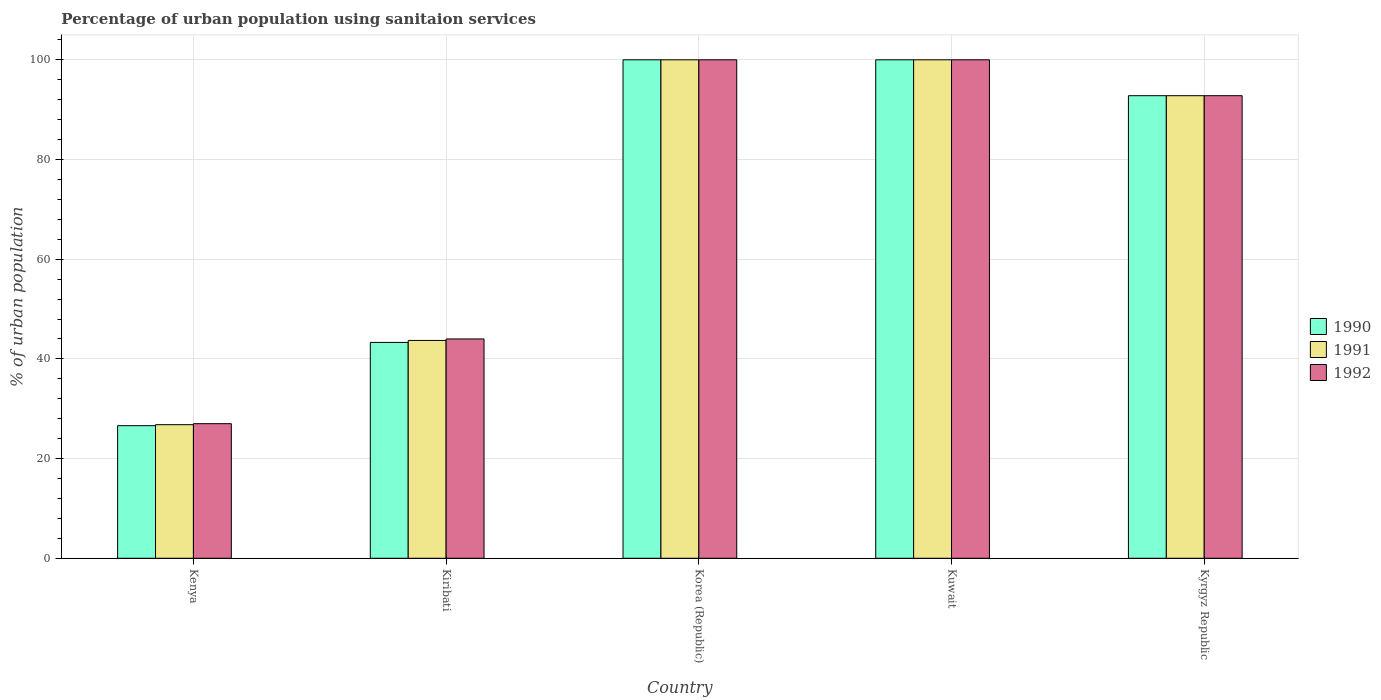How many groups of bars are there?
Provide a succinct answer. 5. Are the number of bars on each tick of the X-axis equal?
Keep it short and to the point. Yes. How many bars are there on the 3rd tick from the left?
Offer a terse response. 3. How many bars are there on the 1st tick from the right?
Make the answer very short. 3. What is the label of the 5th group of bars from the left?
Ensure brevity in your answer.  Kyrgyz Republic. In how many cases, is the number of bars for a given country not equal to the number of legend labels?
Your response must be concise. 0. What is the percentage of urban population using sanitaion services in 1992 in Kenya?
Keep it short and to the point. 27. In which country was the percentage of urban population using sanitaion services in 1991 minimum?
Provide a short and direct response. Kenya. What is the total percentage of urban population using sanitaion services in 1991 in the graph?
Provide a succinct answer. 363.3. What is the difference between the percentage of urban population using sanitaion services in 1990 in Kuwait and that in Kyrgyz Republic?
Your answer should be compact. 7.2. What is the difference between the percentage of urban population using sanitaion services in 1991 in Korea (Republic) and the percentage of urban population using sanitaion services in 1990 in Kenya?
Give a very brief answer. 73.4. What is the average percentage of urban population using sanitaion services in 1992 per country?
Keep it short and to the point. 72.76. What is the difference between the percentage of urban population using sanitaion services of/in 1992 and percentage of urban population using sanitaion services of/in 1990 in Kenya?
Provide a short and direct response. 0.4. In how many countries, is the percentage of urban population using sanitaion services in 1990 greater than 28 %?
Your answer should be very brief. 4. What is the ratio of the percentage of urban population using sanitaion services in 1990 in Kiribati to that in Kuwait?
Give a very brief answer. 0.43. Is the percentage of urban population using sanitaion services in 1990 in Kuwait less than that in Kyrgyz Republic?
Your response must be concise. No. Is the difference between the percentage of urban population using sanitaion services in 1992 in Kiribati and Korea (Republic) greater than the difference between the percentage of urban population using sanitaion services in 1990 in Kiribati and Korea (Republic)?
Offer a terse response. Yes. What is the difference between the highest and the second highest percentage of urban population using sanitaion services in 1992?
Make the answer very short. 7.2. What is the difference between the highest and the lowest percentage of urban population using sanitaion services in 1992?
Offer a terse response. 73. In how many countries, is the percentage of urban population using sanitaion services in 1990 greater than the average percentage of urban population using sanitaion services in 1990 taken over all countries?
Give a very brief answer. 3. What does the 1st bar from the left in Kenya represents?
Offer a very short reply. 1990. What does the 1st bar from the right in Kenya represents?
Keep it short and to the point. 1992. Is it the case that in every country, the sum of the percentage of urban population using sanitaion services in 1990 and percentage of urban population using sanitaion services in 1992 is greater than the percentage of urban population using sanitaion services in 1991?
Provide a short and direct response. Yes. Are all the bars in the graph horizontal?
Keep it short and to the point. No. Does the graph contain any zero values?
Keep it short and to the point. No. Does the graph contain grids?
Give a very brief answer. Yes. How many legend labels are there?
Provide a short and direct response. 3. What is the title of the graph?
Your response must be concise. Percentage of urban population using sanitaion services. What is the label or title of the Y-axis?
Provide a short and direct response. % of urban population. What is the % of urban population of 1990 in Kenya?
Your answer should be very brief. 26.6. What is the % of urban population in 1991 in Kenya?
Ensure brevity in your answer.  26.8. What is the % of urban population of 1990 in Kiribati?
Ensure brevity in your answer.  43.3. What is the % of urban population of 1991 in Kiribati?
Offer a terse response. 43.7. What is the % of urban population in 1990 in Korea (Republic)?
Provide a succinct answer. 100. What is the % of urban population of 1991 in Kuwait?
Offer a very short reply. 100. What is the % of urban population of 1990 in Kyrgyz Republic?
Offer a very short reply. 92.8. What is the % of urban population in 1991 in Kyrgyz Republic?
Your response must be concise. 92.8. What is the % of urban population of 1992 in Kyrgyz Republic?
Offer a terse response. 92.8. Across all countries, what is the maximum % of urban population in 1990?
Provide a short and direct response. 100. Across all countries, what is the maximum % of urban population of 1991?
Ensure brevity in your answer.  100. Across all countries, what is the minimum % of urban population in 1990?
Give a very brief answer. 26.6. Across all countries, what is the minimum % of urban population in 1991?
Your answer should be very brief. 26.8. What is the total % of urban population in 1990 in the graph?
Offer a terse response. 362.7. What is the total % of urban population of 1991 in the graph?
Keep it short and to the point. 363.3. What is the total % of urban population in 1992 in the graph?
Offer a terse response. 363.8. What is the difference between the % of urban population in 1990 in Kenya and that in Kiribati?
Provide a short and direct response. -16.7. What is the difference between the % of urban population of 1991 in Kenya and that in Kiribati?
Ensure brevity in your answer.  -16.9. What is the difference between the % of urban population of 1992 in Kenya and that in Kiribati?
Your response must be concise. -17. What is the difference between the % of urban population of 1990 in Kenya and that in Korea (Republic)?
Offer a very short reply. -73.4. What is the difference between the % of urban population of 1991 in Kenya and that in Korea (Republic)?
Ensure brevity in your answer.  -73.2. What is the difference between the % of urban population in 1992 in Kenya and that in Korea (Republic)?
Ensure brevity in your answer.  -73. What is the difference between the % of urban population of 1990 in Kenya and that in Kuwait?
Provide a succinct answer. -73.4. What is the difference between the % of urban population of 1991 in Kenya and that in Kuwait?
Offer a terse response. -73.2. What is the difference between the % of urban population in 1992 in Kenya and that in Kuwait?
Offer a terse response. -73. What is the difference between the % of urban population of 1990 in Kenya and that in Kyrgyz Republic?
Ensure brevity in your answer.  -66.2. What is the difference between the % of urban population in 1991 in Kenya and that in Kyrgyz Republic?
Your response must be concise. -66. What is the difference between the % of urban population in 1992 in Kenya and that in Kyrgyz Republic?
Offer a terse response. -65.8. What is the difference between the % of urban population of 1990 in Kiribati and that in Korea (Republic)?
Ensure brevity in your answer.  -56.7. What is the difference between the % of urban population in 1991 in Kiribati and that in Korea (Republic)?
Ensure brevity in your answer.  -56.3. What is the difference between the % of urban population in 1992 in Kiribati and that in Korea (Republic)?
Provide a short and direct response. -56. What is the difference between the % of urban population in 1990 in Kiribati and that in Kuwait?
Keep it short and to the point. -56.7. What is the difference between the % of urban population of 1991 in Kiribati and that in Kuwait?
Your answer should be very brief. -56.3. What is the difference between the % of urban population of 1992 in Kiribati and that in Kuwait?
Make the answer very short. -56. What is the difference between the % of urban population in 1990 in Kiribati and that in Kyrgyz Republic?
Give a very brief answer. -49.5. What is the difference between the % of urban population in 1991 in Kiribati and that in Kyrgyz Republic?
Keep it short and to the point. -49.1. What is the difference between the % of urban population in 1992 in Kiribati and that in Kyrgyz Republic?
Give a very brief answer. -48.8. What is the difference between the % of urban population of 1992 in Korea (Republic) and that in Kuwait?
Make the answer very short. 0. What is the difference between the % of urban population of 1991 in Kuwait and that in Kyrgyz Republic?
Your response must be concise. 7.2. What is the difference between the % of urban population in 1990 in Kenya and the % of urban population in 1991 in Kiribati?
Provide a succinct answer. -17.1. What is the difference between the % of urban population in 1990 in Kenya and the % of urban population in 1992 in Kiribati?
Make the answer very short. -17.4. What is the difference between the % of urban population of 1991 in Kenya and the % of urban population of 1992 in Kiribati?
Your answer should be compact. -17.2. What is the difference between the % of urban population in 1990 in Kenya and the % of urban population in 1991 in Korea (Republic)?
Your response must be concise. -73.4. What is the difference between the % of urban population of 1990 in Kenya and the % of urban population of 1992 in Korea (Republic)?
Provide a succinct answer. -73.4. What is the difference between the % of urban population of 1991 in Kenya and the % of urban population of 1992 in Korea (Republic)?
Ensure brevity in your answer.  -73.2. What is the difference between the % of urban population of 1990 in Kenya and the % of urban population of 1991 in Kuwait?
Offer a very short reply. -73.4. What is the difference between the % of urban population of 1990 in Kenya and the % of urban population of 1992 in Kuwait?
Keep it short and to the point. -73.4. What is the difference between the % of urban population of 1991 in Kenya and the % of urban population of 1992 in Kuwait?
Your answer should be compact. -73.2. What is the difference between the % of urban population in 1990 in Kenya and the % of urban population in 1991 in Kyrgyz Republic?
Keep it short and to the point. -66.2. What is the difference between the % of urban population in 1990 in Kenya and the % of urban population in 1992 in Kyrgyz Republic?
Your answer should be very brief. -66.2. What is the difference between the % of urban population in 1991 in Kenya and the % of urban population in 1992 in Kyrgyz Republic?
Keep it short and to the point. -66. What is the difference between the % of urban population of 1990 in Kiribati and the % of urban population of 1991 in Korea (Republic)?
Your answer should be compact. -56.7. What is the difference between the % of urban population of 1990 in Kiribati and the % of urban population of 1992 in Korea (Republic)?
Provide a succinct answer. -56.7. What is the difference between the % of urban population in 1991 in Kiribati and the % of urban population in 1992 in Korea (Republic)?
Offer a very short reply. -56.3. What is the difference between the % of urban population of 1990 in Kiribati and the % of urban population of 1991 in Kuwait?
Ensure brevity in your answer.  -56.7. What is the difference between the % of urban population of 1990 in Kiribati and the % of urban population of 1992 in Kuwait?
Provide a succinct answer. -56.7. What is the difference between the % of urban population of 1991 in Kiribati and the % of urban population of 1992 in Kuwait?
Offer a terse response. -56.3. What is the difference between the % of urban population in 1990 in Kiribati and the % of urban population in 1991 in Kyrgyz Republic?
Give a very brief answer. -49.5. What is the difference between the % of urban population of 1990 in Kiribati and the % of urban population of 1992 in Kyrgyz Republic?
Make the answer very short. -49.5. What is the difference between the % of urban population of 1991 in Kiribati and the % of urban population of 1992 in Kyrgyz Republic?
Give a very brief answer. -49.1. What is the difference between the % of urban population of 1990 in Korea (Republic) and the % of urban population of 1992 in Kuwait?
Provide a short and direct response. 0. What is the difference between the % of urban population in 1991 in Korea (Republic) and the % of urban population in 1992 in Kuwait?
Provide a succinct answer. 0. What is the difference between the % of urban population of 1990 in Korea (Republic) and the % of urban population of 1991 in Kyrgyz Republic?
Make the answer very short. 7.2. What is the difference between the % of urban population in 1990 in Kuwait and the % of urban population in 1991 in Kyrgyz Republic?
Your answer should be very brief. 7.2. What is the difference between the % of urban population of 1990 in Kuwait and the % of urban population of 1992 in Kyrgyz Republic?
Give a very brief answer. 7.2. What is the difference between the % of urban population in 1991 in Kuwait and the % of urban population in 1992 in Kyrgyz Republic?
Ensure brevity in your answer.  7.2. What is the average % of urban population of 1990 per country?
Provide a short and direct response. 72.54. What is the average % of urban population in 1991 per country?
Provide a short and direct response. 72.66. What is the average % of urban population of 1992 per country?
Provide a succinct answer. 72.76. What is the difference between the % of urban population in 1990 and % of urban population in 1991 in Kenya?
Provide a short and direct response. -0.2. What is the difference between the % of urban population of 1991 and % of urban population of 1992 in Kenya?
Your response must be concise. -0.2. What is the difference between the % of urban population in 1990 and % of urban population in 1991 in Kiribati?
Your response must be concise. -0.4. What is the difference between the % of urban population of 1991 and % of urban population of 1992 in Kiribati?
Give a very brief answer. -0.3. What is the difference between the % of urban population of 1990 and % of urban population of 1992 in Korea (Republic)?
Keep it short and to the point. 0. What is the difference between the % of urban population in 1991 and % of urban population in 1992 in Korea (Republic)?
Your response must be concise. 0. What is the difference between the % of urban population in 1990 and % of urban population in 1991 in Kuwait?
Give a very brief answer. 0. What is the difference between the % of urban population of 1991 and % of urban population of 1992 in Kuwait?
Ensure brevity in your answer.  0. What is the difference between the % of urban population in 1990 and % of urban population in 1991 in Kyrgyz Republic?
Provide a succinct answer. 0. What is the difference between the % of urban population of 1990 and % of urban population of 1992 in Kyrgyz Republic?
Offer a very short reply. 0. What is the ratio of the % of urban population in 1990 in Kenya to that in Kiribati?
Your answer should be compact. 0.61. What is the ratio of the % of urban population in 1991 in Kenya to that in Kiribati?
Make the answer very short. 0.61. What is the ratio of the % of urban population of 1992 in Kenya to that in Kiribati?
Your response must be concise. 0.61. What is the ratio of the % of urban population in 1990 in Kenya to that in Korea (Republic)?
Ensure brevity in your answer.  0.27. What is the ratio of the % of urban population in 1991 in Kenya to that in Korea (Republic)?
Your answer should be very brief. 0.27. What is the ratio of the % of urban population of 1992 in Kenya to that in Korea (Republic)?
Offer a terse response. 0.27. What is the ratio of the % of urban population of 1990 in Kenya to that in Kuwait?
Keep it short and to the point. 0.27. What is the ratio of the % of urban population in 1991 in Kenya to that in Kuwait?
Provide a succinct answer. 0.27. What is the ratio of the % of urban population of 1992 in Kenya to that in Kuwait?
Give a very brief answer. 0.27. What is the ratio of the % of urban population of 1990 in Kenya to that in Kyrgyz Republic?
Ensure brevity in your answer.  0.29. What is the ratio of the % of urban population in 1991 in Kenya to that in Kyrgyz Republic?
Make the answer very short. 0.29. What is the ratio of the % of urban population of 1992 in Kenya to that in Kyrgyz Republic?
Offer a terse response. 0.29. What is the ratio of the % of urban population of 1990 in Kiribati to that in Korea (Republic)?
Ensure brevity in your answer.  0.43. What is the ratio of the % of urban population of 1991 in Kiribati to that in Korea (Republic)?
Offer a very short reply. 0.44. What is the ratio of the % of urban population of 1992 in Kiribati to that in Korea (Republic)?
Ensure brevity in your answer.  0.44. What is the ratio of the % of urban population of 1990 in Kiribati to that in Kuwait?
Ensure brevity in your answer.  0.43. What is the ratio of the % of urban population of 1991 in Kiribati to that in Kuwait?
Your answer should be very brief. 0.44. What is the ratio of the % of urban population in 1992 in Kiribati to that in Kuwait?
Provide a succinct answer. 0.44. What is the ratio of the % of urban population in 1990 in Kiribati to that in Kyrgyz Republic?
Offer a very short reply. 0.47. What is the ratio of the % of urban population in 1991 in Kiribati to that in Kyrgyz Republic?
Offer a terse response. 0.47. What is the ratio of the % of urban population of 1992 in Kiribati to that in Kyrgyz Republic?
Keep it short and to the point. 0.47. What is the ratio of the % of urban population in 1990 in Korea (Republic) to that in Kuwait?
Offer a very short reply. 1. What is the ratio of the % of urban population of 1992 in Korea (Republic) to that in Kuwait?
Give a very brief answer. 1. What is the ratio of the % of urban population of 1990 in Korea (Republic) to that in Kyrgyz Republic?
Provide a short and direct response. 1.08. What is the ratio of the % of urban population of 1991 in Korea (Republic) to that in Kyrgyz Republic?
Keep it short and to the point. 1.08. What is the ratio of the % of urban population in 1992 in Korea (Republic) to that in Kyrgyz Republic?
Provide a short and direct response. 1.08. What is the ratio of the % of urban population of 1990 in Kuwait to that in Kyrgyz Republic?
Give a very brief answer. 1.08. What is the ratio of the % of urban population of 1991 in Kuwait to that in Kyrgyz Republic?
Ensure brevity in your answer.  1.08. What is the ratio of the % of urban population of 1992 in Kuwait to that in Kyrgyz Republic?
Your answer should be compact. 1.08. What is the difference between the highest and the second highest % of urban population in 1991?
Your response must be concise. 0. What is the difference between the highest and the lowest % of urban population of 1990?
Your answer should be very brief. 73.4. What is the difference between the highest and the lowest % of urban population in 1991?
Offer a terse response. 73.2. What is the difference between the highest and the lowest % of urban population in 1992?
Your answer should be very brief. 73. 